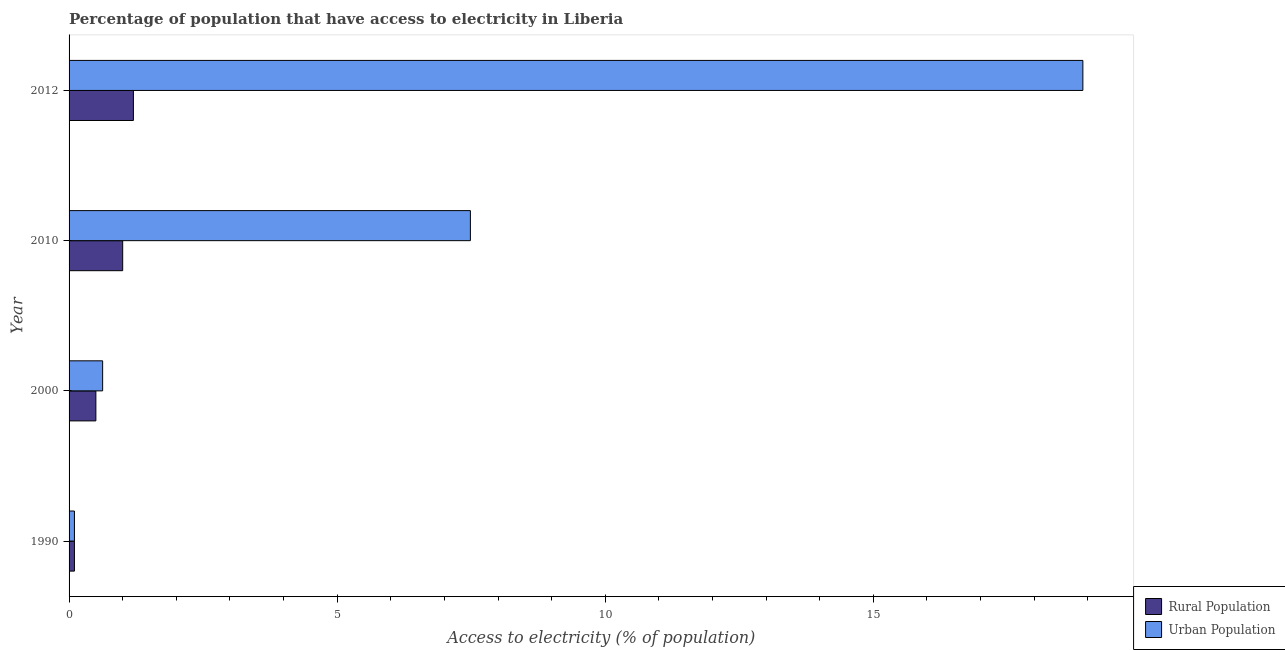How many different coloured bars are there?
Offer a terse response. 2. How many groups of bars are there?
Provide a succinct answer. 4. Are the number of bars on each tick of the Y-axis equal?
Keep it short and to the point. Yes. How many bars are there on the 4th tick from the top?
Your answer should be very brief. 2. How many bars are there on the 3rd tick from the bottom?
Make the answer very short. 2. What is the label of the 2nd group of bars from the top?
Make the answer very short. 2010. What is the percentage of urban population having access to electricity in 2000?
Your answer should be very brief. 0.63. Across all years, what is the maximum percentage of rural population having access to electricity?
Provide a succinct answer. 1.2. In which year was the percentage of rural population having access to electricity maximum?
Make the answer very short. 2012. What is the total percentage of urban population having access to electricity in the graph?
Provide a succinct answer. 27.12. What is the difference between the percentage of urban population having access to electricity in 1990 and that in 2012?
Offer a very short reply. -18.81. What is the difference between the percentage of urban population having access to electricity in 2000 and the percentage of rural population having access to electricity in 2010?
Offer a very short reply. -0.37. What is the average percentage of rural population having access to electricity per year?
Give a very brief answer. 0.7. In the year 2012, what is the difference between the percentage of rural population having access to electricity and percentage of urban population having access to electricity?
Provide a short and direct response. -17.71. What is the ratio of the percentage of rural population having access to electricity in 1990 to that in 2012?
Make the answer very short. 0.08. Is the percentage of urban population having access to electricity in 2000 less than that in 2010?
Ensure brevity in your answer.  Yes. Is the sum of the percentage of urban population having access to electricity in 2000 and 2010 greater than the maximum percentage of rural population having access to electricity across all years?
Offer a terse response. Yes. What does the 2nd bar from the top in 1990 represents?
Offer a terse response. Rural Population. What does the 1st bar from the bottom in 2000 represents?
Provide a succinct answer. Rural Population. Are all the bars in the graph horizontal?
Keep it short and to the point. Yes. How many years are there in the graph?
Provide a succinct answer. 4. What is the difference between two consecutive major ticks on the X-axis?
Offer a terse response. 5. Where does the legend appear in the graph?
Make the answer very short. Bottom right. How many legend labels are there?
Provide a short and direct response. 2. How are the legend labels stacked?
Ensure brevity in your answer.  Vertical. What is the title of the graph?
Offer a terse response. Percentage of population that have access to electricity in Liberia. Does "Automatic Teller Machines" appear as one of the legend labels in the graph?
Your answer should be compact. No. What is the label or title of the X-axis?
Provide a short and direct response. Access to electricity (% of population). What is the label or title of the Y-axis?
Your answer should be very brief. Year. What is the Access to electricity (% of population) in Rural Population in 1990?
Ensure brevity in your answer.  0.1. What is the Access to electricity (% of population) in Urban Population in 1990?
Give a very brief answer. 0.1. What is the Access to electricity (% of population) in Urban Population in 2000?
Keep it short and to the point. 0.63. What is the Access to electricity (% of population) of Urban Population in 2010?
Ensure brevity in your answer.  7.49. What is the Access to electricity (% of population) in Rural Population in 2012?
Ensure brevity in your answer.  1.2. What is the Access to electricity (% of population) in Urban Population in 2012?
Keep it short and to the point. 18.91. Across all years, what is the maximum Access to electricity (% of population) of Rural Population?
Keep it short and to the point. 1.2. Across all years, what is the maximum Access to electricity (% of population) in Urban Population?
Your answer should be very brief. 18.91. Across all years, what is the minimum Access to electricity (% of population) in Rural Population?
Offer a very short reply. 0.1. Across all years, what is the minimum Access to electricity (% of population) in Urban Population?
Provide a succinct answer. 0.1. What is the total Access to electricity (% of population) of Urban Population in the graph?
Offer a very short reply. 27.12. What is the difference between the Access to electricity (% of population) in Urban Population in 1990 and that in 2000?
Keep it short and to the point. -0.53. What is the difference between the Access to electricity (% of population) in Urban Population in 1990 and that in 2010?
Provide a short and direct response. -7.39. What is the difference between the Access to electricity (% of population) in Urban Population in 1990 and that in 2012?
Give a very brief answer. -18.81. What is the difference between the Access to electricity (% of population) in Rural Population in 2000 and that in 2010?
Offer a very short reply. -0.5. What is the difference between the Access to electricity (% of population) in Urban Population in 2000 and that in 2010?
Offer a very short reply. -6.86. What is the difference between the Access to electricity (% of population) in Rural Population in 2000 and that in 2012?
Offer a very short reply. -0.7. What is the difference between the Access to electricity (% of population) of Urban Population in 2000 and that in 2012?
Provide a short and direct response. -18.28. What is the difference between the Access to electricity (% of population) in Urban Population in 2010 and that in 2012?
Give a very brief answer. -11.42. What is the difference between the Access to electricity (% of population) of Rural Population in 1990 and the Access to electricity (% of population) of Urban Population in 2000?
Make the answer very short. -0.53. What is the difference between the Access to electricity (% of population) in Rural Population in 1990 and the Access to electricity (% of population) in Urban Population in 2010?
Keep it short and to the point. -7.39. What is the difference between the Access to electricity (% of population) of Rural Population in 1990 and the Access to electricity (% of population) of Urban Population in 2012?
Provide a short and direct response. -18.81. What is the difference between the Access to electricity (% of population) of Rural Population in 2000 and the Access to electricity (% of population) of Urban Population in 2010?
Your answer should be compact. -6.99. What is the difference between the Access to electricity (% of population) in Rural Population in 2000 and the Access to electricity (% of population) in Urban Population in 2012?
Make the answer very short. -18.41. What is the difference between the Access to electricity (% of population) of Rural Population in 2010 and the Access to electricity (% of population) of Urban Population in 2012?
Your answer should be compact. -17.91. What is the average Access to electricity (% of population) in Urban Population per year?
Your answer should be very brief. 6.78. In the year 1990, what is the difference between the Access to electricity (% of population) of Rural Population and Access to electricity (% of population) of Urban Population?
Provide a short and direct response. 0. In the year 2000, what is the difference between the Access to electricity (% of population) of Rural Population and Access to electricity (% of population) of Urban Population?
Give a very brief answer. -0.13. In the year 2010, what is the difference between the Access to electricity (% of population) in Rural Population and Access to electricity (% of population) in Urban Population?
Offer a very short reply. -6.49. In the year 2012, what is the difference between the Access to electricity (% of population) in Rural Population and Access to electricity (% of population) in Urban Population?
Your answer should be compact. -17.71. What is the ratio of the Access to electricity (% of population) in Urban Population in 1990 to that in 2000?
Keep it short and to the point. 0.16. What is the ratio of the Access to electricity (% of population) of Rural Population in 1990 to that in 2010?
Your answer should be compact. 0.1. What is the ratio of the Access to electricity (% of population) of Urban Population in 1990 to that in 2010?
Your answer should be compact. 0.01. What is the ratio of the Access to electricity (% of population) in Rural Population in 1990 to that in 2012?
Provide a succinct answer. 0.08. What is the ratio of the Access to electricity (% of population) of Urban Population in 1990 to that in 2012?
Make the answer very short. 0.01. What is the ratio of the Access to electricity (% of population) of Urban Population in 2000 to that in 2010?
Ensure brevity in your answer.  0.08. What is the ratio of the Access to electricity (% of population) of Rural Population in 2000 to that in 2012?
Your response must be concise. 0.42. What is the ratio of the Access to electricity (% of population) of Urban Population in 2000 to that in 2012?
Your answer should be very brief. 0.03. What is the ratio of the Access to electricity (% of population) in Urban Population in 2010 to that in 2012?
Offer a very short reply. 0.4. What is the difference between the highest and the second highest Access to electricity (% of population) in Rural Population?
Your answer should be very brief. 0.2. What is the difference between the highest and the second highest Access to electricity (% of population) of Urban Population?
Your answer should be compact. 11.42. What is the difference between the highest and the lowest Access to electricity (% of population) in Rural Population?
Provide a short and direct response. 1.1. What is the difference between the highest and the lowest Access to electricity (% of population) of Urban Population?
Keep it short and to the point. 18.81. 